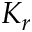Convert formula to latex. <formula><loc_0><loc_0><loc_500><loc_500>K _ { r }</formula> 